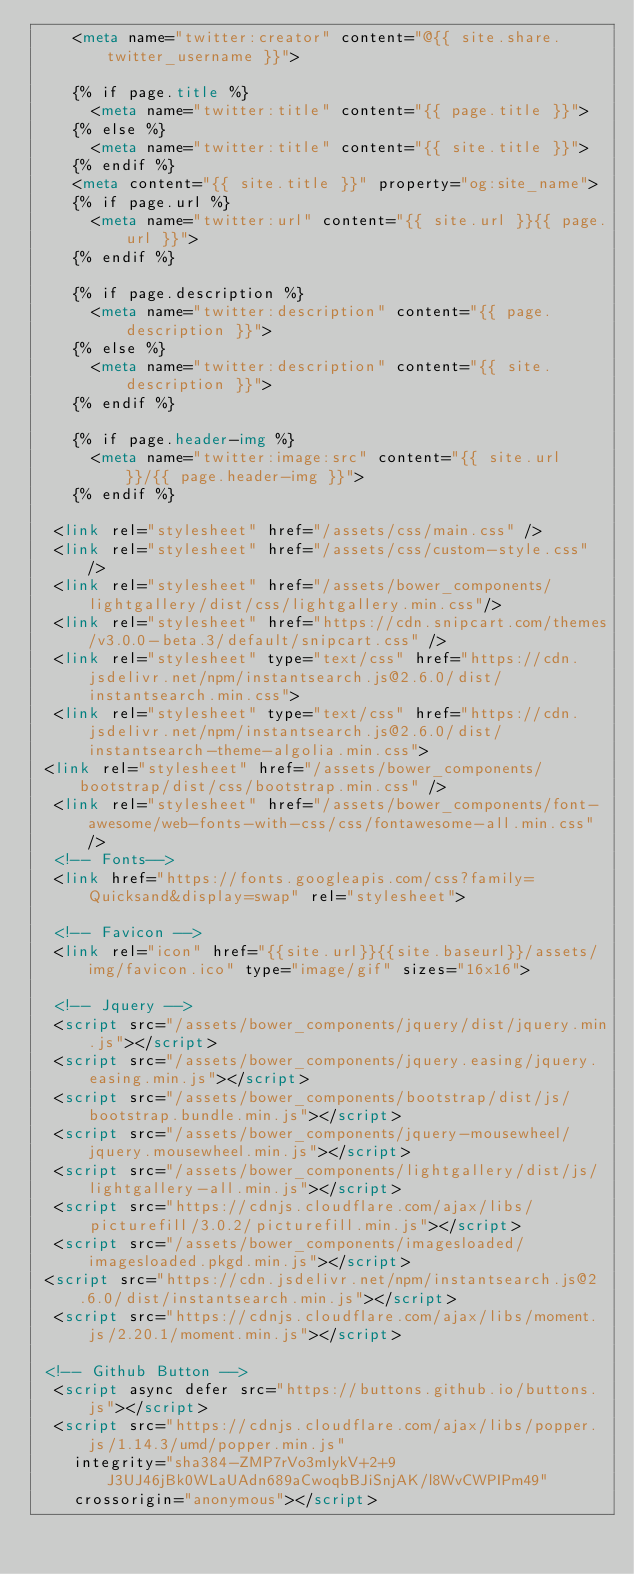<code> <loc_0><loc_0><loc_500><loc_500><_HTML_>    <meta name="twitter:creator" content="@{{ site.share.twitter_username }}">

    {% if page.title %}
      <meta name="twitter:title" content="{{ page.title }}">
    {% else %}
      <meta name="twitter:title" content="{{ site.title }}">
    {% endif %}
    <meta content="{{ site.title }}" property="og:site_name">
    {% if page.url %}
      <meta name="twitter:url" content="{{ site.url }}{{ page.url }}">
    {% endif %}

    {% if page.description %}
      <meta name="twitter:description" content="{{ page.description }}">
    {% else %}
      <meta name="twitter:description" content="{{ site.description }}">
    {% endif %}

    {% if page.header-img %}
      <meta name="twitter:image:src" content="{{ site.url }}/{{ page.header-img }}">
    {% endif %}

  <link rel="stylesheet" href="/assets/css/main.css" />
  <link rel="stylesheet" href="/assets/css/custom-style.css" />
  <link rel="stylesheet" href="/assets/bower_components/lightgallery/dist/css/lightgallery.min.css"/>
  <link rel="stylesheet" href="https://cdn.snipcart.com/themes/v3.0.0-beta.3/default/snipcart.css" />
  <link rel="stylesheet" type="text/css" href="https://cdn.jsdelivr.net/npm/instantsearch.js@2.6.0/dist/instantsearch.min.css">
  <link rel="stylesheet" type="text/css" href="https://cdn.jsdelivr.net/npm/instantsearch.js@2.6.0/dist/instantsearch-theme-algolia.min.css">
 <link rel="stylesheet" href="/assets/bower_components/bootstrap/dist/css/bootstrap.min.css" />
  <link rel="stylesheet" href="/assets/bower_components/font-awesome/web-fonts-with-css/css/fontawesome-all.min.css" />
  <!-- Fonts-->
  <link href="https://fonts.googleapis.com/css?family=Quicksand&display=swap" rel="stylesheet">

  <!-- Favicon -->
  <link rel="icon" href="{{site.url}}{{site.baseurl}}/assets/img/favicon.ico" type="image/gif" sizes="16x16">

  <!-- Jquery -->
  <script src="/assets/bower_components/jquery/dist/jquery.min.js"></script>
  <script src="/assets/bower_components/jquery.easing/jquery.easing.min.js"></script>
  <script src="/assets/bower_components/bootstrap/dist/js/bootstrap.bundle.min.js"></script>
  <script src="/assets/bower_components/jquery-mousewheel/jquery.mousewheel.min.js"></script>
  <script src="/assets/bower_components/lightgallery/dist/js/lightgallery-all.min.js"></script>
  <script src="https://cdnjs.cloudflare.com/ajax/libs/picturefill/3.0.2/picturefill.min.js"></script>
  <script src="/assets/bower_components/imagesloaded/imagesloaded.pkgd.min.js"></script>
 <script src="https://cdn.jsdelivr.net/npm/instantsearch.js@2.6.0/dist/instantsearch.min.js"></script>
  <script src="https://cdnjs.cloudflare.com/ajax/libs/moment.js/2.20.1/moment.min.js"></script>

 <!-- Github Button -->
  <script async defer src="https://buttons.github.io/buttons.js"></script>
  <script src="https://cdnjs.cloudflare.com/ajax/libs/popper.js/1.14.3/umd/popper.min.js"
    integrity="sha384-ZMP7rVo3mIykV+2+9J3UJ46jBk0WLaUAdn689aCwoqbBJiSnjAK/l8WvCWPIPm49"
    crossorigin="anonymous"></script></code> 